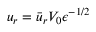Convert formula to latex. <formula><loc_0><loc_0><loc_500><loc_500>u _ { r } = \bar { u } _ { r } V _ { 0 } { \epsilon } ^ { - 1 / 2 }</formula> 